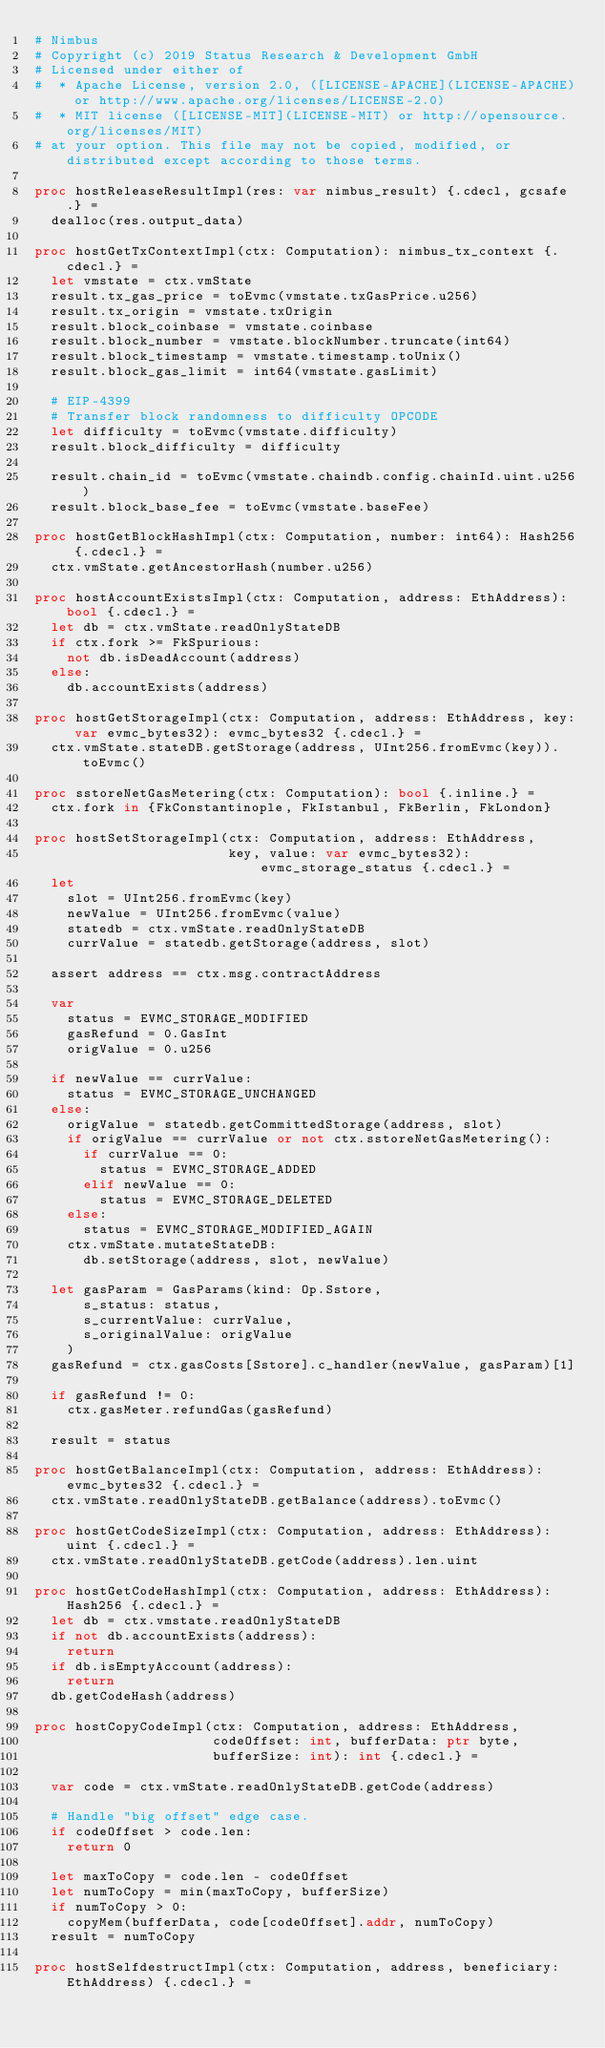<code> <loc_0><loc_0><loc_500><loc_500><_Nim_># Nimbus
# Copyright (c) 2019 Status Research & Development GmbH
# Licensed under either of
#  * Apache License, version 2.0, ([LICENSE-APACHE](LICENSE-APACHE) or http://www.apache.org/licenses/LICENSE-2.0)
#  * MIT license ([LICENSE-MIT](LICENSE-MIT) or http://opensource.org/licenses/MIT)
# at your option. This file may not be copied, modified, or distributed except according to those terms.

proc hostReleaseResultImpl(res: var nimbus_result) {.cdecl, gcsafe.} =
  dealloc(res.output_data)

proc hostGetTxContextImpl(ctx: Computation): nimbus_tx_context {.cdecl.} =
  let vmstate = ctx.vmState
  result.tx_gas_price = toEvmc(vmstate.txGasPrice.u256)
  result.tx_origin = vmstate.txOrigin
  result.block_coinbase = vmstate.coinbase
  result.block_number = vmstate.blockNumber.truncate(int64)
  result.block_timestamp = vmstate.timestamp.toUnix()
  result.block_gas_limit = int64(vmstate.gasLimit)

  # EIP-4399
  # Transfer block randomness to difficulty OPCODE
  let difficulty = toEvmc(vmstate.difficulty)
  result.block_difficulty = difficulty

  result.chain_id = toEvmc(vmstate.chaindb.config.chainId.uint.u256)
  result.block_base_fee = toEvmc(vmstate.baseFee)

proc hostGetBlockHashImpl(ctx: Computation, number: int64): Hash256 {.cdecl.} =
  ctx.vmState.getAncestorHash(number.u256)

proc hostAccountExistsImpl(ctx: Computation, address: EthAddress): bool {.cdecl.} =
  let db = ctx.vmState.readOnlyStateDB
  if ctx.fork >= FkSpurious:
    not db.isDeadAccount(address)
  else:
    db.accountExists(address)

proc hostGetStorageImpl(ctx: Computation, address: EthAddress, key: var evmc_bytes32): evmc_bytes32 {.cdecl.} =
  ctx.vmState.stateDB.getStorage(address, UInt256.fromEvmc(key)).toEvmc()

proc sstoreNetGasMetering(ctx: Computation): bool {.inline.} =
  ctx.fork in {FkConstantinople, FkIstanbul, FkBerlin, FkLondon}

proc hostSetStorageImpl(ctx: Computation, address: EthAddress,
                        key, value: var evmc_bytes32): evmc_storage_status {.cdecl.} =
  let
    slot = UInt256.fromEvmc(key)
    newValue = UInt256.fromEvmc(value)
    statedb = ctx.vmState.readOnlyStateDB
    currValue = statedb.getStorage(address, slot)

  assert address == ctx.msg.contractAddress

  var
    status = EVMC_STORAGE_MODIFIED
    gasRefund = 0.GasInt
    origValue = 0.u256

  if newValue == currValue:
    status = EVMC_STORAGE_UNCHANGED
  else:
    origValue = statedb.getCommittedStorage(address, slot)
    if origValue == currValue or not ctx.sstoreNetGasMetering():
      if currValue == 0:
        status = EVMC_STORAGE_ADDED
      elif newValue == 0:
        status = EVMC_STORAGE_DELETED
    else:
      status = EVMC_STORAGE_MODIFIED_AGAIN
    ctx.vmState.mutateStateDB:
      db.setStorage(address, slot, newValue)

  let gasParam = GasParams(kind: Op.Sstore,
      s_status: status,
      s_currentValue: currValue,
      s_originalValue: origValue
    )
  gasRefund = ctx.gasCosts[Sstore].c_handler(newValue, gasParam)[1]

  if gasRefund != 0:
    ctx.gasMeter.refundGas(gasRefund)

  result = status

proc hostGetBalanceImpl(ctx: Computation, address: EthAddress): evmc_bytes32 {.cdecl.} =
  ctx.vmState.readOnlyStateDB.getBalance(address).toEvmc()

proc hostGetCodeSizeImpl(ctx: Computation, address: EthAddress): uint {.cdecl.} =
  ctx.vmState.readOnlyStateDB.getCode(address).len.uint

proc hostGetCodeHashImpl(ctx: Computation, address: EthAddress): Hash256 {.cdecl.} =
  let db = ctx.vmstate.readOnlyStateDB
  if not db.accountExists(address):
    return
  if db.isEmptyAccount(address):
    return
  db.getCodeHash(address)

proc hostCopyCodeImpl(ctx: Computation, address: EthAddress,
                      codeOffset: int, bufferData: ptr byte,
                      bufferSize: int): int {.cdecl.} =

  var code = ctx.vmState.readOnlyStateDB.getCode(address)

  # Handle "big offset" edge case.
  if codeOffset > code.len:
    return 0

  let maxToCopy = code.len - codeOffset
  let numToCopy = min(maxToCopy, bufferSize)
  if numToCopy > 0:
    copyMem(bufferData, code[codeOffset].addr, numToCopy)
  result = numToCopy

proc hostSelfdestructImpl(ctx: Computation, address, beneficiary: EthAddress) {.cdecl.} =</code> 